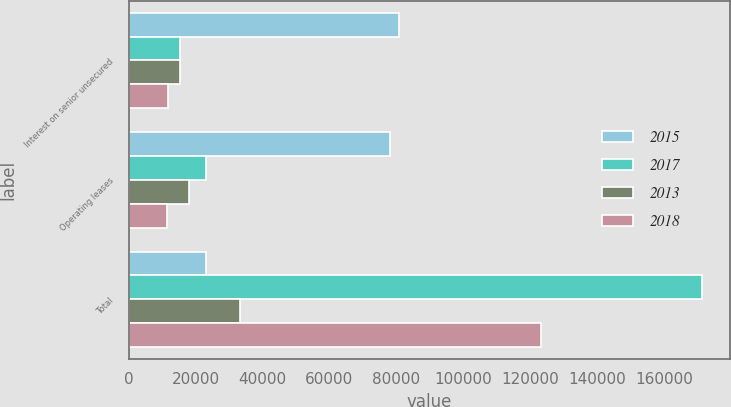Convert chart to OTSL. <chart><loc_0><loc_0><loc_500><loc_500><stacked_bar_chart><ecel><fcel>Interest on senior unsecured<fcel>Operating leases<fcel>Total<nl><fcel>2015<fcel>80721<fcel>78112<fcel>23243<nl><fcel>2017<fcel>15205<fcel>23243<fcel>171229<nl><fcel>2013<fcel>15205<fcel>18135<fcel>33340<nl><fcel>2018<fcel>11768<fcel>11456<fcel>123224<nl></chart> 